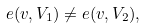<formula> <loc_0><loc_0><loc_500><loc_500>e ( v , V _ { 1 } ) \ne e ( v , V _ { 2 } ) ,</formula> 